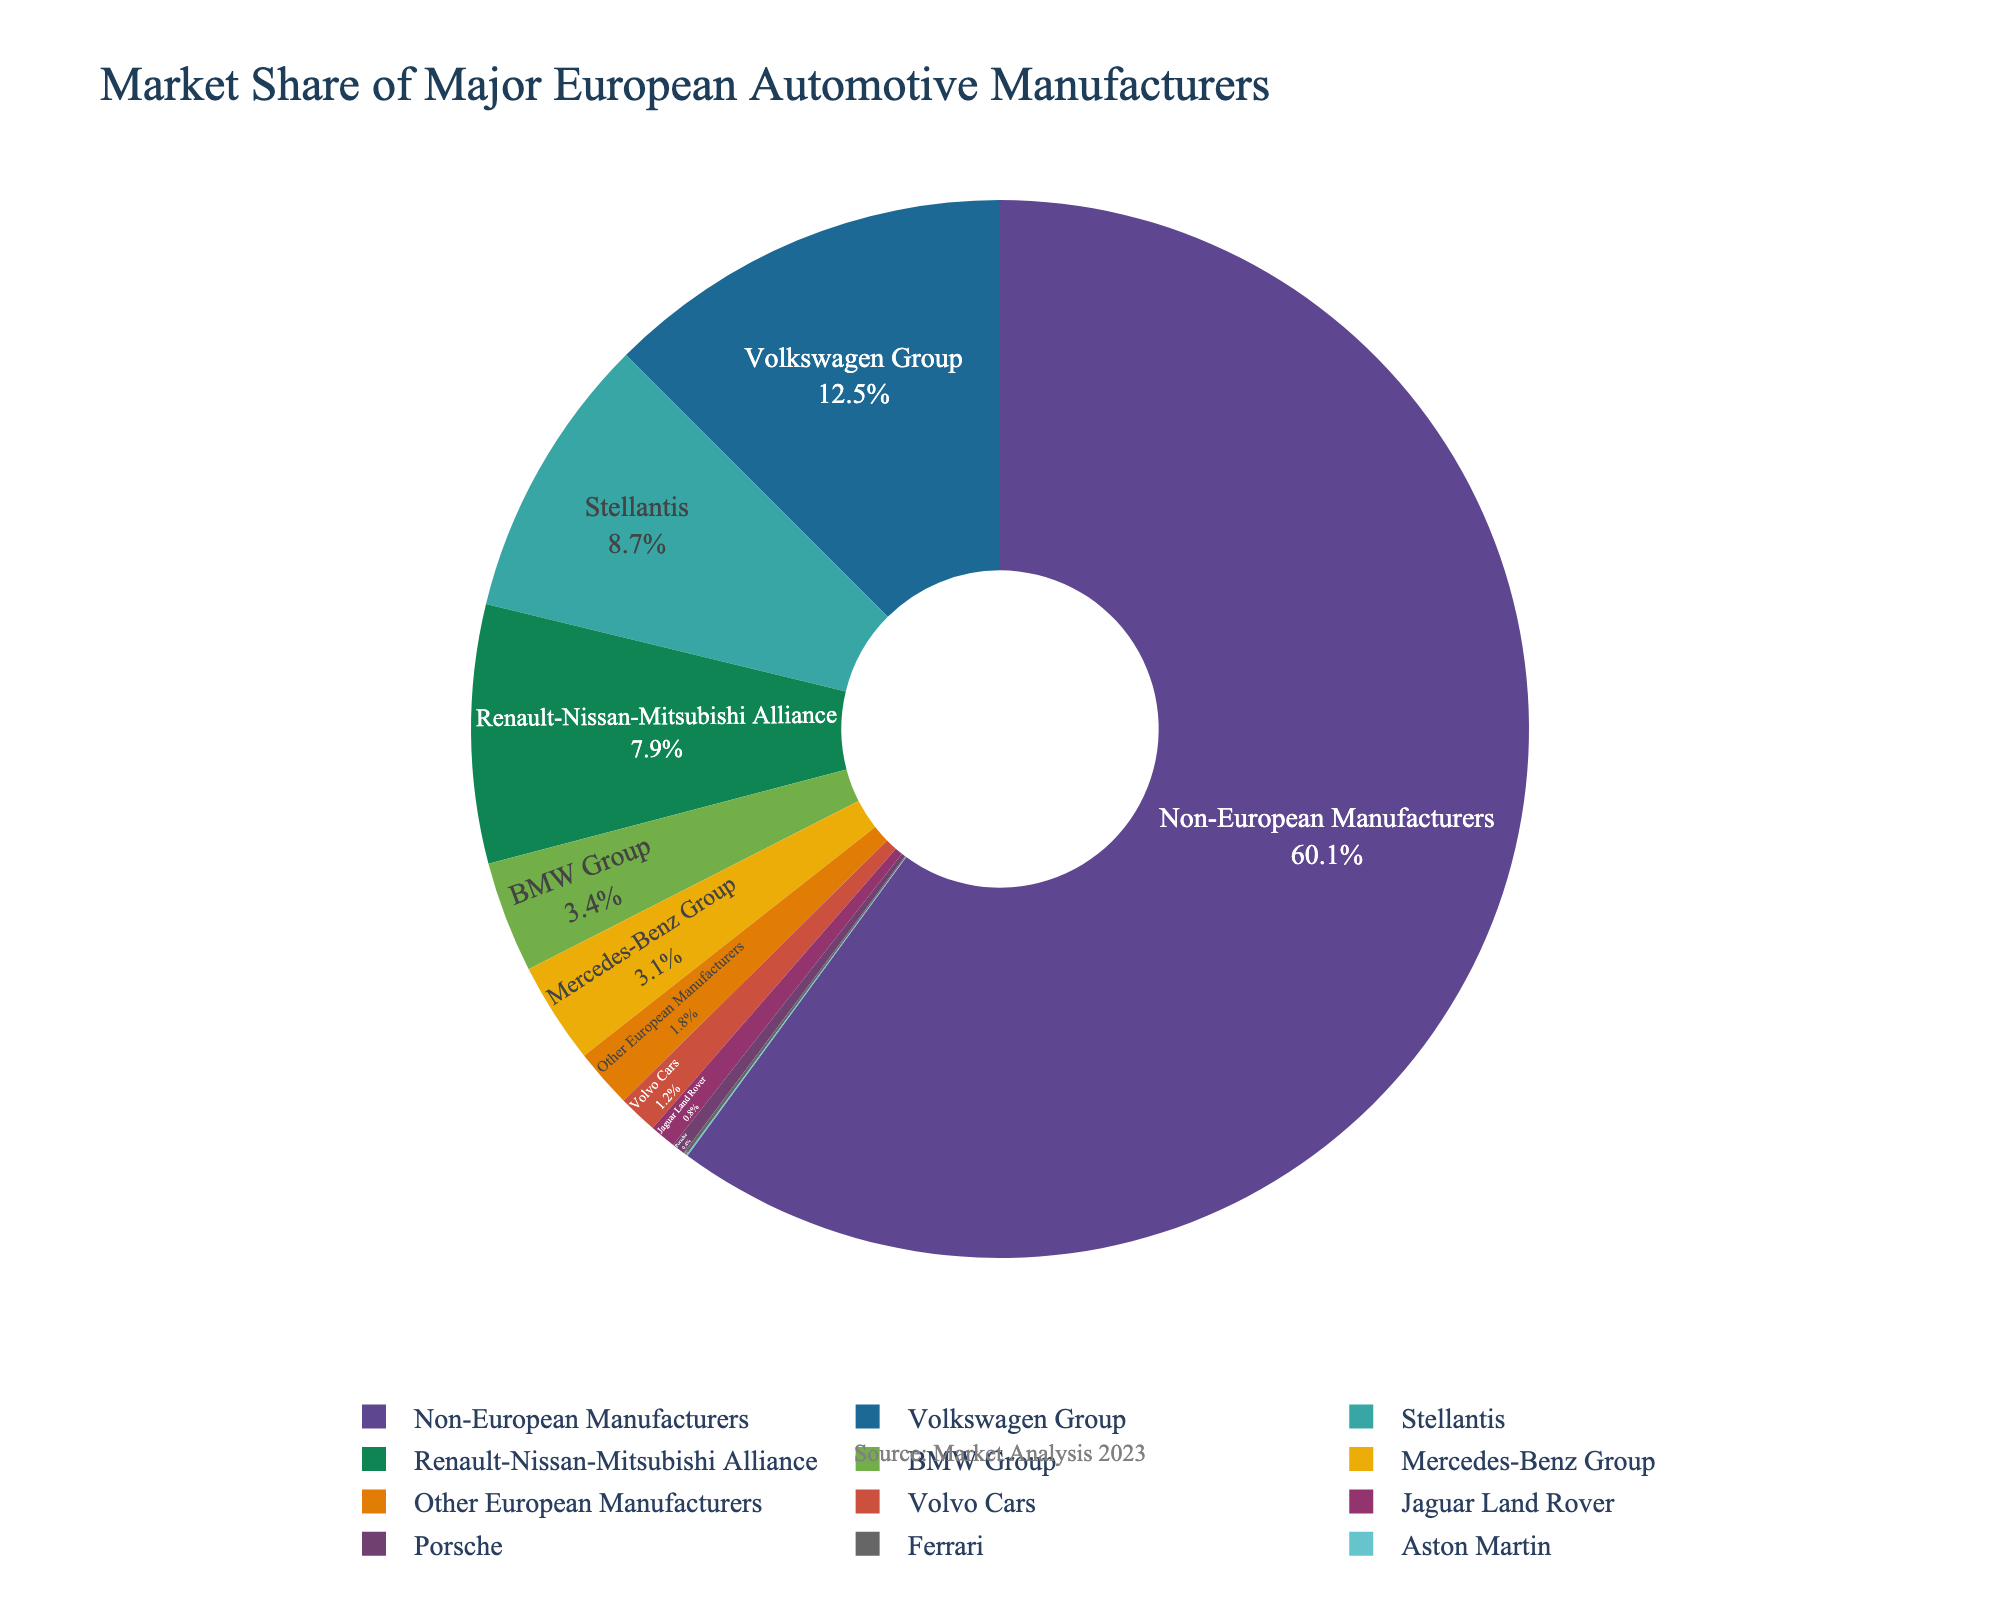Which manufacturer has the highest market share? By examining the pie chart, the segment representing the Volkswagen Group appears the largest. This corresponds to the highest market share in the data, which is 12.5%.
Answer: Volkswagen Group Among the listed European manufacturers, which one has the smallest market share? Visually, the smallest segment corresponds to Ferrari. According to the data, Ferrari has a market share of 0.1%.
Answer: Ferrari What is the combined market share of BMW Group and Mercedes-Benz Group? Summing the market shares of BMW Group (3.4%) and Mercedes-Benz Group (3.1%), we get 3.4% + 3.1% = 6.5%.
Answer: 6.5% Is the market share of non-European manufacturers greater than the combined market share of all European manufacturers? The market share of non-European manufacturers is 60.06%. Summing the shares of all European manufacturers gives 12.5% + 8.7% + 7.9% + 3.4% + 3.1% + 1.2% + 0.1% + 0.04% + 0.8% + 0.4% + 1.8% which is 39.94%. Since 60.06% > 39.94%, the non-European manufacturers have a greater market share.
Answer: Yes Which country has a higher market share, the Renault-Nissan-Mitsubishi Alliance or Stellantis? Consulting the pie chart, the Renault-Nissan-Mitsubishi Alliance has a 7.9% share and Stellantis has an 8.7% share. Thus, Stellantis has a higher market share.
Answer: Stellantis What is the difference in market share between Jaguar Land Rover and Volvo Cars? From the pie chart, Jaguar Land Rover has a market share of 0.8% and Volvo Cars has 1.2%. The difference is 1.2% - 0.8% = 0.4%.
Answer: 0.4% What is the total market share of non-European manufacturers visually represented as a segment of the pie chart? Observing the pie chart, the segment labeled 'Non-European Manufacturers' visually represents the largest portion, which matches the data indicating a 60.06% market share.
Answer: 60.06% Which manufacturer has a market share slightly greater than 3% but less than 4%? By cross-referencing the data and the pie chart, both BMW Group (3.4%) and Mercedes-Benz Group (3.1%) fall within this range, but only Mercedes-Benz Group is in the specified range of slightly more than 3% but less than 4%.
Answer: Mercedes-Benz Group 